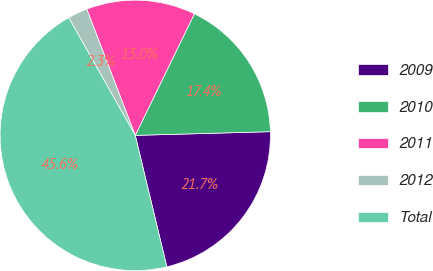Convert chart to OTSL. <chart><loc_0><loc_0><loc_500><loc_500><pie_chart><fcel>2009<fcel>2010<fcel>2011<fcel>2012<fcel>Total<nl><fcel>21.68%<fcel>17.36%<fcel>13.04%<fcel>2.35%<fcel>45.57%<nl></chart> 